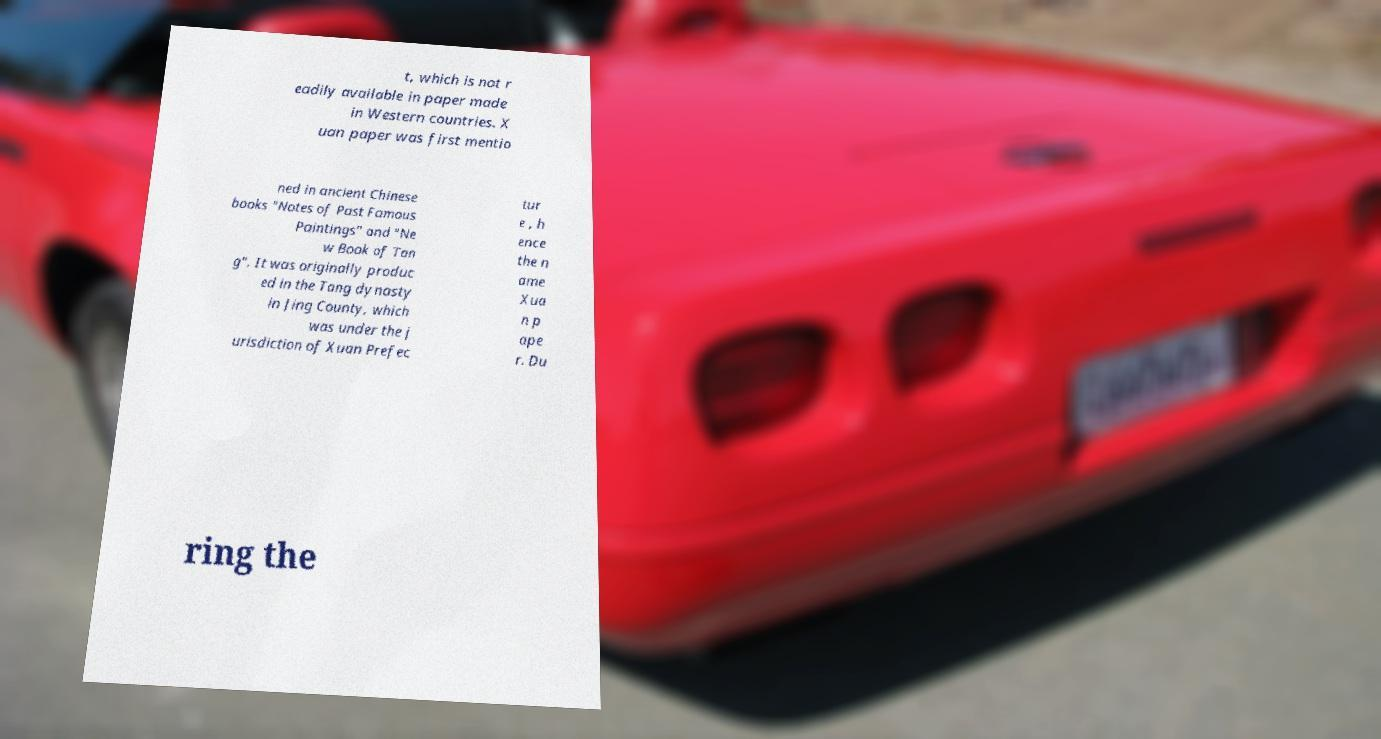Can you accurately transcribe the text from the provided image for me? t, which is not r eadily available in paper made in Western countries. X uan paper was first mentio ned in ancient Chinese books "Notes of Past Famous Paintings" and "Ne w Book of Tan g". It was originally produc ed in the Tang dynasty in Jing County, which was under the j urisdiction of Xuan Prefec tur e , h ence the n ame Xua n p ape r. Du ring the 